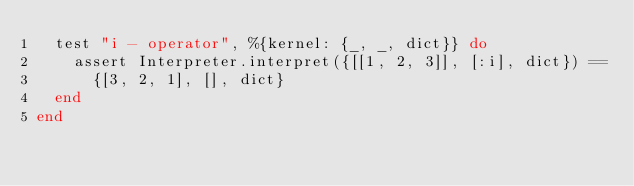<code> <loc_0><loc_0><loc_500><loc_500><_Elixir_>  test "i - operator", %{kernel: {_, _, dict}} do
    assert Interpreter.interpret({[[1, 2, 3]], [:i], dict}) ==
      {[3, 2, 1], [], dict}
  end
end
</code> 